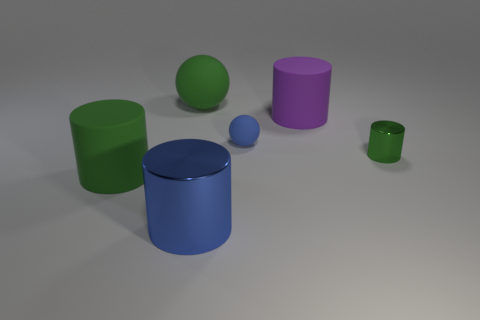Subtract all small green cylinders. How many cylinders are left? 3 Subtract all green cylinders. How many cylinders are left? 2 Add 1 small balls. How many objects exist? 7 Subtract 3 cylinders. How many cylinders are left? 1 Subtract 0 gray balls. How many objects are left? 6 Subtract all spheres. How many objects are left? 4 Subtract all green cylinders. Subtract all green balls. How many cylinders are left? 2 Subtract all purple cubes. How many gray balls are left? 0 Subtract all small blue matte spheres. Subtract all big metallic objects. How many objects are left? 4 Add 3 blue metallic cylinders. How many blue metallic cylinders are left? 4 